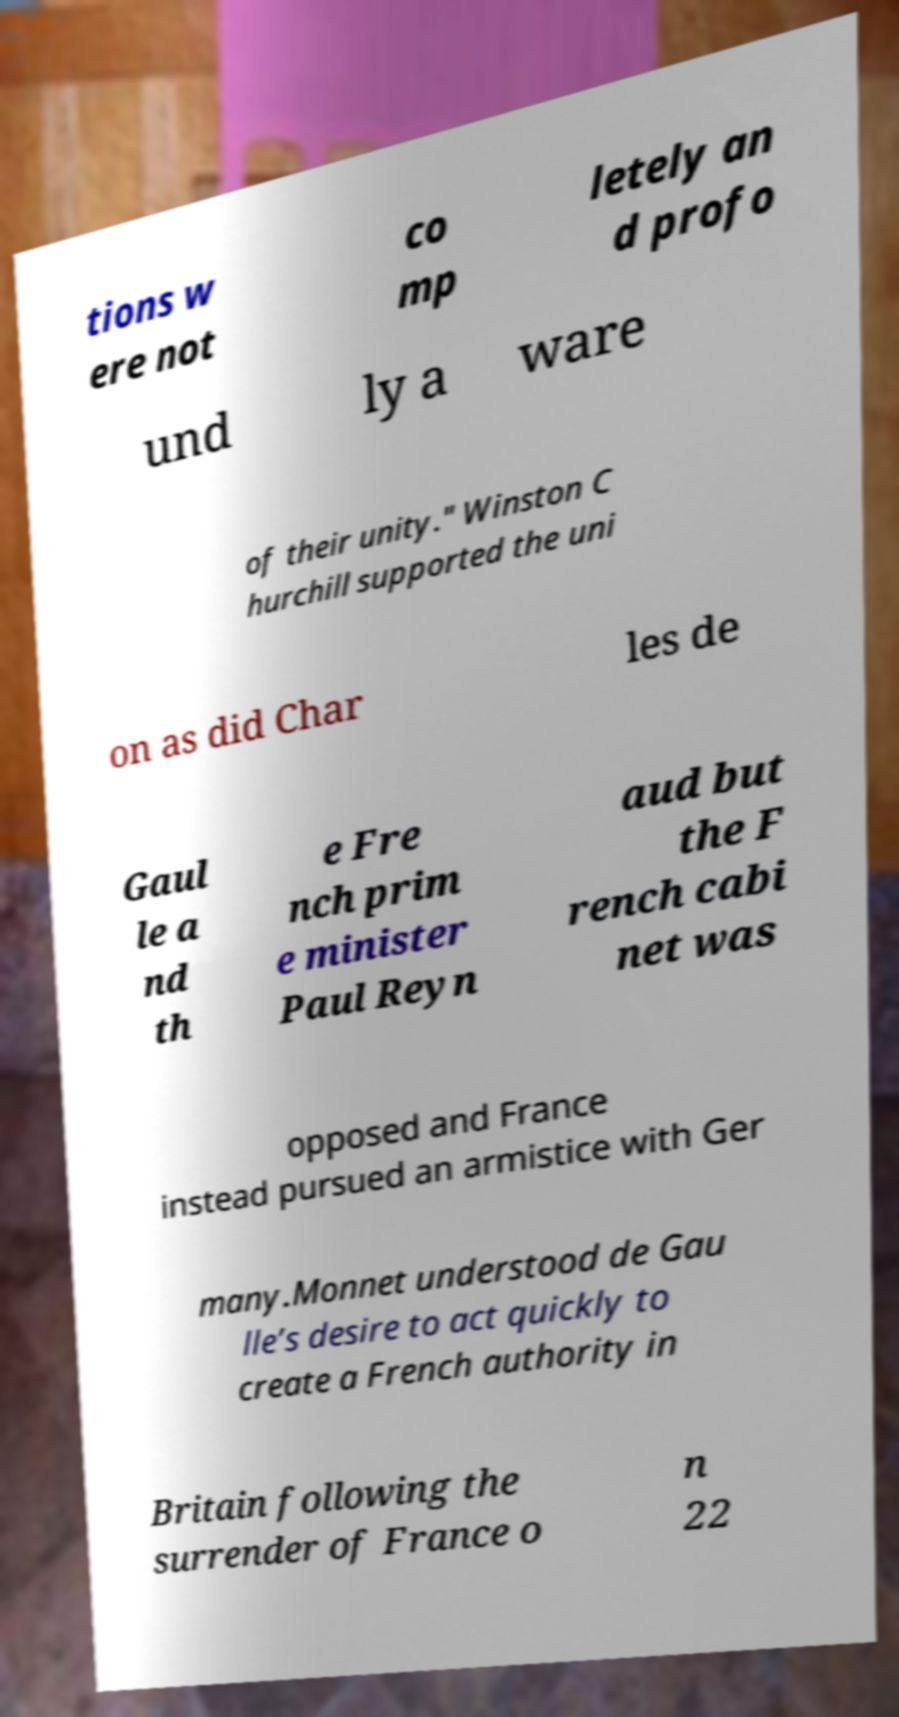There's text embedded in this image that I need extracted. Can you transcribe it verbatim? tions w ere not co mp letely an d profo und ly a ware of their unity." Winston C hurchill supported the uni on as did Char les de Gaul le a nd th e Fre nch prim e minister Paul Reyn aud but the F rench cabi net was opposed and France instead pursued an armistice with Ger many.Monnet understood de Gau lle’s desire to act quickly to create a French authority in Britain following the surrender of France o n 22 